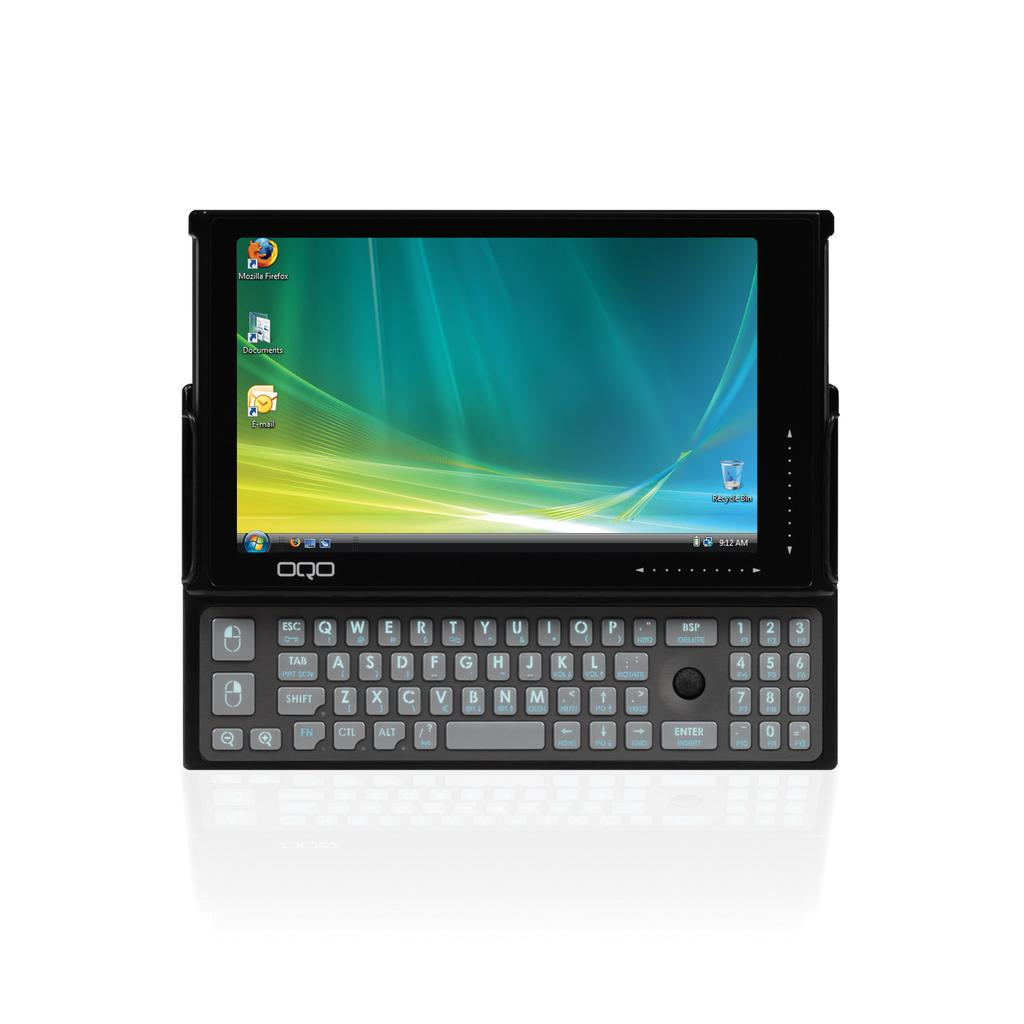<image>
Write a terse but informative summary of the picture. OQO miniture computer running windows xp that has firefox installed 